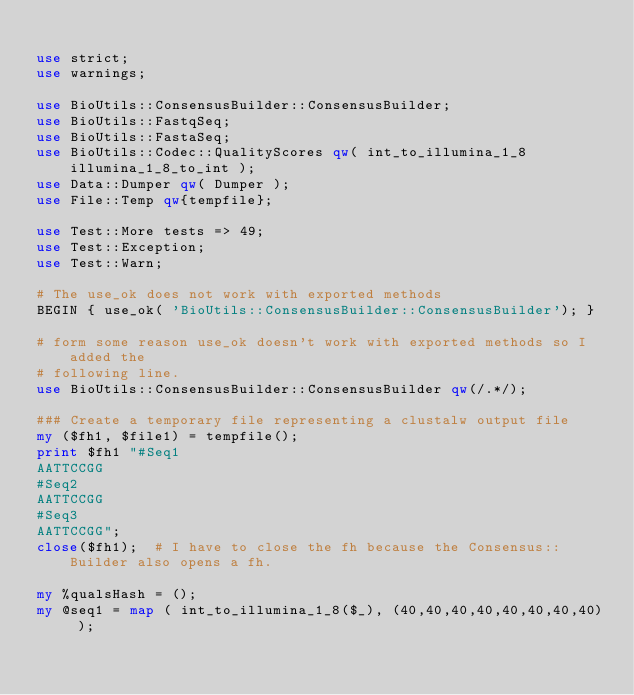Convert code to text. <code><loc_0><loc_0><loc_500><loc_500><_Perl_>
use strict;
use warnings;

use BioUtils::ConsensusBuilder::ConsensusBuilder;
use BioUtils::FastqSeq;
use BioUtils::FastaSeq;
use BioUtils::Codec::QualityScores qw( int_to_illumina_1_8 illumina_1_8_to_int );
use Data::Dumper qw( Dumper );
use File::Temp qw{tempfile};

use Test::More tests => 49;
use Test::Exception;
use Test::Warn;

# The use_ok does not work with exported methods
BEGIN { use_ok( 'BioUtils::ConsensusBuilder::ConsensusBuilder'); }

# form some reason use_ok doesn't work with exported methods so I added the
# following line.
use BioUtils::ConsensusBuilder::ConsensusBuilder qw(/.*/);

### Create a temporary file representing a clustalw output file
my ($fh1, $file1) = tempfile();
print $fh1 "#Seq1
AATTCCGG
#Seq2
AATTCCGG
#Seq3
AATTCCGG";
close($fh1);  # I have to close the fh because the Consensus::Builder also opens a fh.

my %qualsHash = ();
my @seq1 = map ( int_to_illumina_1_8($_), (40,40,40,40,40,40,40,40) );</code> 